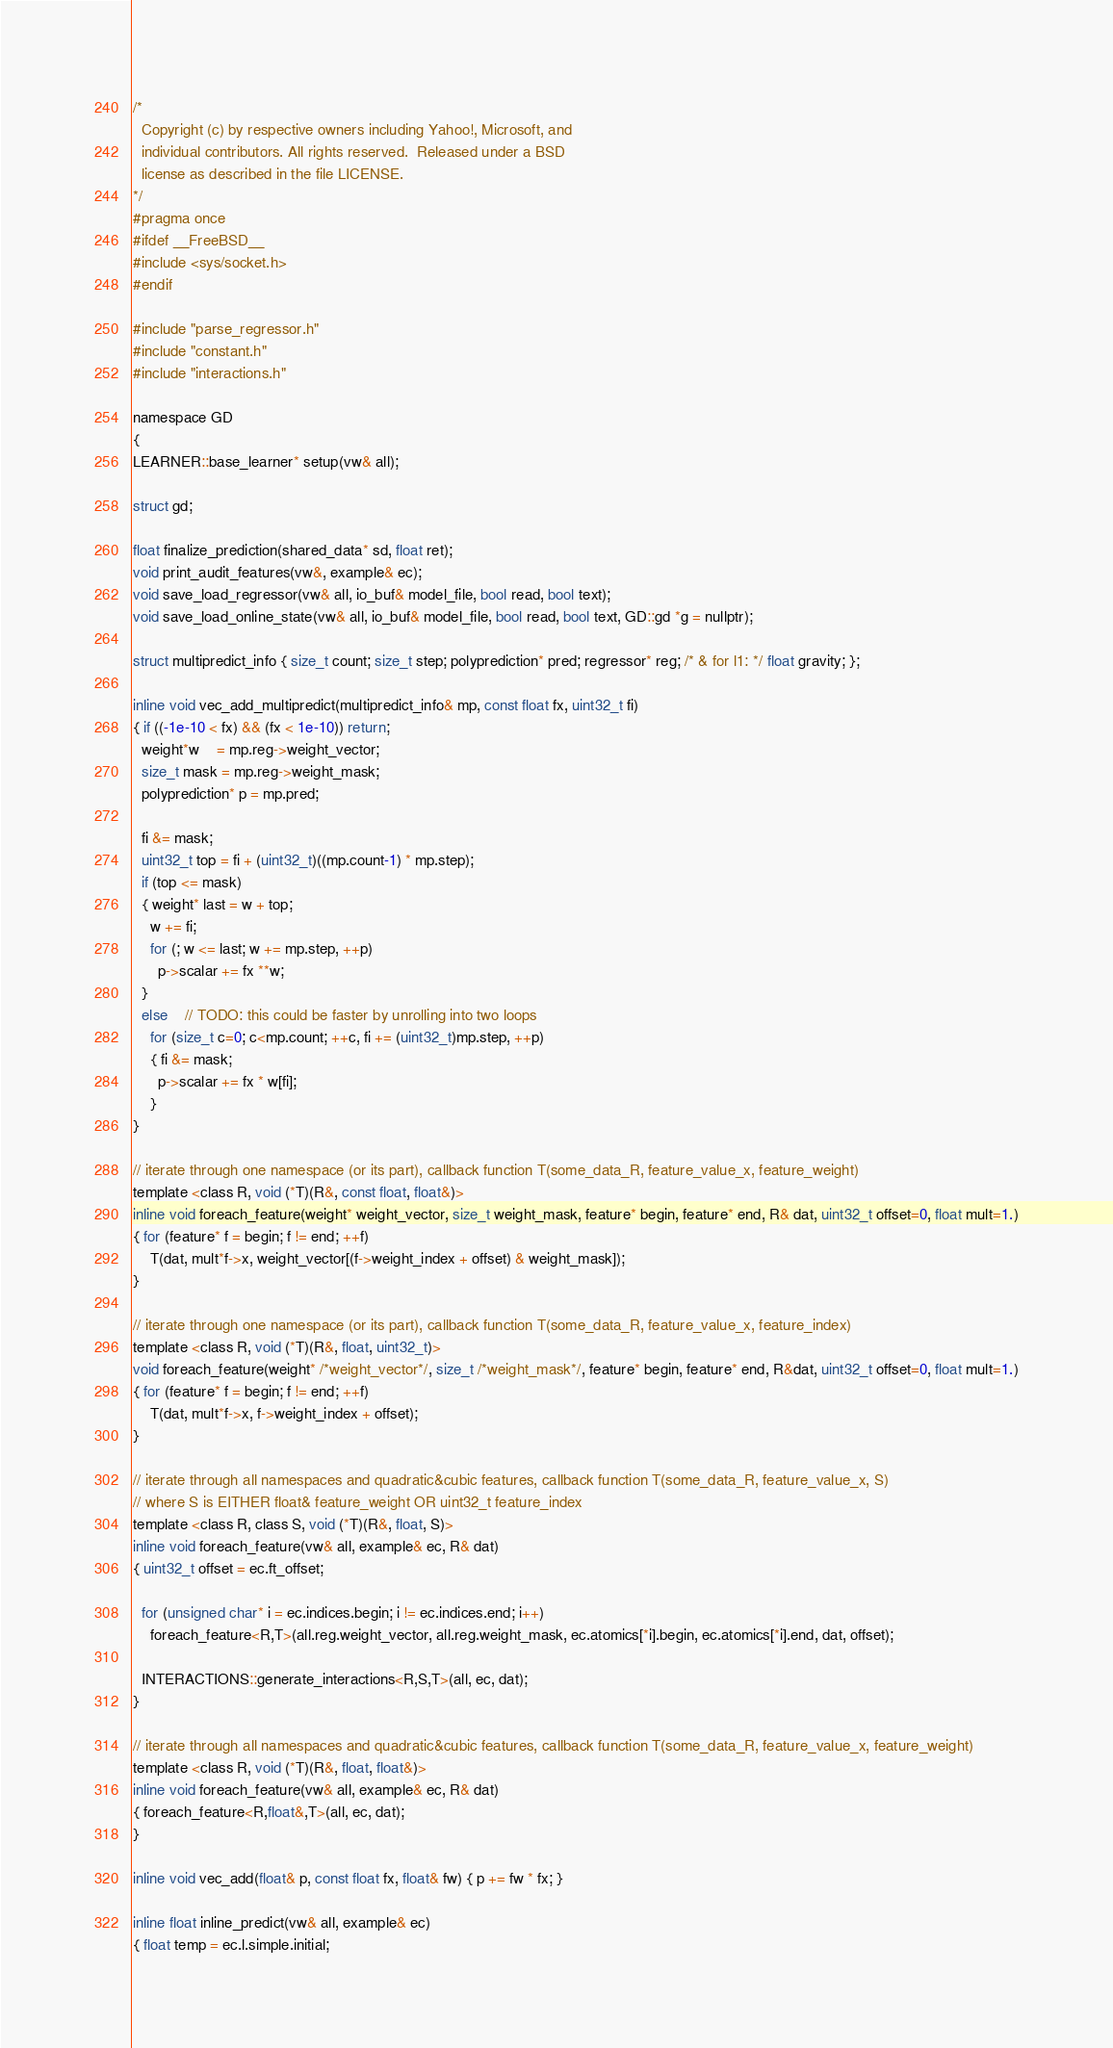<code> <loc_0><loc_0><loc_500><loc_500><_C_>/*
  Copyright (c) by respective owners including Yahoo!, Microsoft, and
  individual contributors. All rights reserved.  Released under a BSD
  license as described in the file LICENSE.
*/
#pragma once
#ifdef __FreeBSD__
#include <sys/socket.h>
#endif

#include "parse_regressor.h"
#include "constant.h"
#include "interactions.h"

namespace GD
{
LEARNER::base_learner* setup(vw& all);

struct gd;

float finalize_prediction(shared_data* sd, float ret);
void print_audit_features(vw&, example& ec);
void save_load_regressor(vw& all, io_buf& model_file, bool read, bool text);
void save_load_online_state(vw& all, io_buf& model_file, bool read, bool text, GD::gd *g = nullptr);

struct multipredict_info { size_t count; size_t step; polyprediction* pred; regressor* reg; /* & for l1: */ float gravity; };

inline void vec_add_multipredict(multipredict_info& mp, const float fx, uint32_t fi)
{ if ((-1e-10 < fx) && (fx < 1e-10)) return;
  weight*w    = mp.reg->weight_vector;
  size_t mask = mp.reg->weight_mask;
  polyprediction* p = mp.pred;

  fi &= mask;
  uint32_t top = fi + (uint32_t)((mp.count-1) * mp.step);
  if (top <= mask)
  { weight* last = w + top;
    w += fi;
    for (; w <= last; w += mp.step, ++p)
      p->scalar += fx **w;
  }
  else    // TODO: this could be faster by unrolling into two loops
    for (size_t c=0; c<mp.count; ++c, fi += (uint32_t)mp.step, ++p)
    { fi &= mask;
      p->scalar += fx * w[fi];
    }
}

// iterate through one namespace (or its part), callback function T(some_data_R, feature_value_x, feature_weight)
template <class R, void (*T)(R&, const float, float&)>
inline void foreach_feature(weight* weight_vector, size_t weight_mask, feature* begin, feature* end, R& dat, uint32_t offset=0, float mult=1.)
{ for (feature* f = begin; f != end; ++f)
    T(dat, mult*f->x, weight_vector[(f->weight_index + offset) & weight_mask]);
}

// iterate through one namespace (or its part), callback function T(some_data_R, feature_value_x, feature_index)
template <class R, void (*T)(R&, float, uint32_t)>
void foreach_feature(weight* /*weight_vector*/, size_t /*weight_mask*/, feature* begin, feature* end, R&dat, uint32_t offset=0, float mult=1.)
{ for (feature* f = begin; f != end; ++f)
    T(dat, mult*f->x, f->weight_index + offset);
}

// iterate through all namespaces and quadratic&cubic features, callback function T(some_data_R, feature_value_x, S)
// where S is EITHER float& feature_weight OR uint32_t feature_index
template <class R, class S, void (*T)(R&, float, S)>
inline void foreach_feature(vw& all, example& ec, R& dat)
{ uint32_t offset = ec.ft_offset;

  for (unsigned char* i = ec.indices.begin; i != ec.indices.end; i++)
    foreach_feature<R,T>(all.reg.weight_vector, all.reg.weight_mask, ec.atomics[*i].begin, ec.atomics[*i].end, dat, offset);

  INTERACTIONS::generate_interactions<R,S,T>(all, ec, dat);
}

// iterate through all namespaces and quadratic&cubic features, callback function T(some_data_R, feature_value_x, feature_weight)
template <class R, void (*T)(R&, float, float&)>
inline void foreach_feature(vw& all, example& ec, R& dat)
{ foreach_feature<R,float&,T>(all, ec, dat);
}

inline void vec_add(float& p, const float fx, float& fw) { p += fw * fx; }

inline float inline_predict(vw& all, example& ec)
{ float temp = ec.l.simple.initial;</code> 